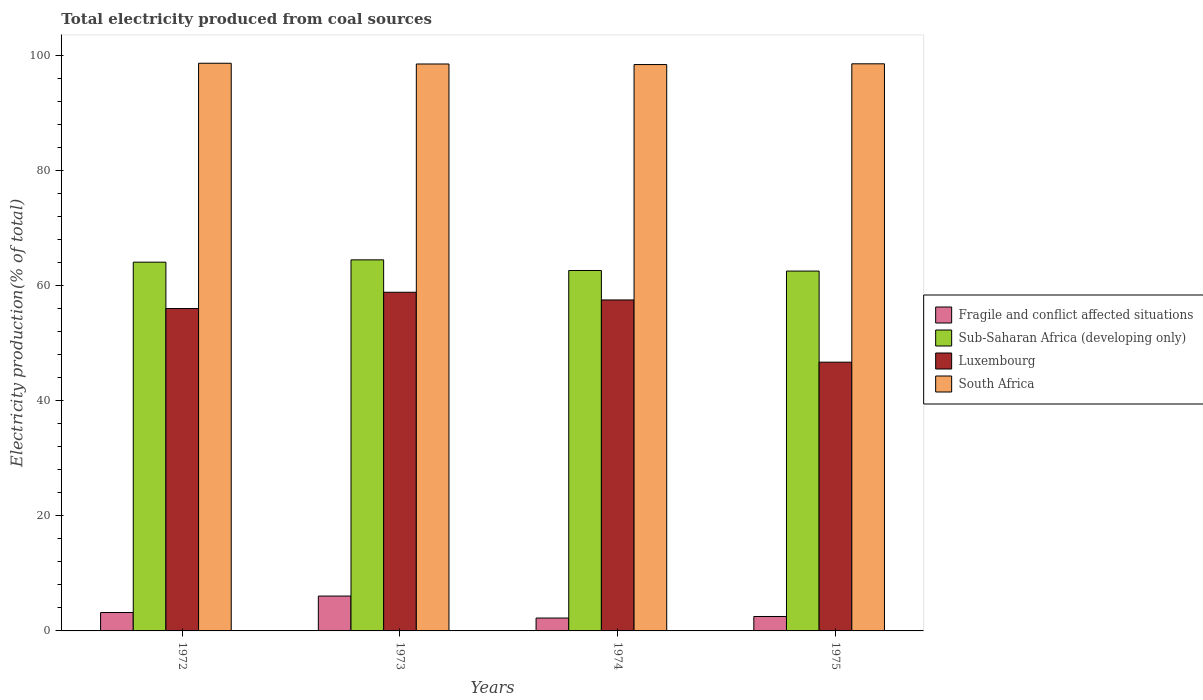Are the number of bars per tick equal to the number of legend labels?
Offer a terse response. Yes. What is the label of the 2nd group of bars from the left?
Ensure brevity in your answer.  1973. What is the total electricity produced in South Africa in 1972?
Your response must be concise. 98.6. Across all years, what is the maximum total electricity produced in Fragile and conflict affected situations?
Your response must be concise. 6.06. Across all years, what is the minimum total electricity produced in Sub-Saharan Africa (developing only)?
Your answer should be very brief. 62.5. In which year was the total electricity produced in South Africa maximum?
Give a very brief answer. 1972. In which year was the total electricity produced in Luxembourg minimum?
Make the answer very short. 1975. What is the total total electricity produced in Fragile and conflict affected situations in the graph?
Provide a succinct answer. 14. What is the difference between the total electricity produced in Fragile and conflict affected situations in 1973 and that in 1974?
Offer a very short reply. 3.82. What is the difference between the total electricity produced in Sub-Saharan Africa (developing only) in 1973 and the total electricity produced in Fragile and conflict affected situations in 1974?
Offer a terse response. 62.21. What is the average total electricity produced in Luxembourg per year?
Make the answer very short. 54.75. In the year 1975, what is the difference between the total electricity produced in Sub-Saharan Africa (developing only) and total electricity produced in Luxembourg?
Make the answer very short. 15.82. In how many years, is the total electricity produced in Sub-Saharan Africa (developing only) greater than 24 %?
Offer a very short reply. 4. What is the ratio of the total electricity produced in Fragile and conflict affected situations in 1972 to that in 1973?
Give a very brief answer. 0.53. Is the total electricity produced in Sub-Saharan Africa (developing only) in 1973 less than that in 1974?
Your answer should be compact. No. What is the difference between the highest and the second highest total electricity produced in Sub-Saharan Africa (developing only)?
Offer a terse response. 0.4. What is the difference between the highest and the lowest total electricity produced in Fragile and conflict affected situations?
Offer a very short reply. 3.82. Is the sum of the total electricity produced in Sub-Saharan Africa (developing only) in 1973 and 1975 greater than the maximum total electricity produced in Fragile and conflict affected situations across all years?
Ensure brevity in your answer.  Yes. Is it the case that in every year, the sum of the total electricity produced in South Africa and total electricity produced in Luxembourg is greater than the sum of total electricity produced in Sub-Saharan Africa (developing only) and total electricity produced in Fragile and conflict affected situations?
Your answer should be compact. Yes. What does the 3rd bar from the left in 1972 represents?
Your response must be concise. Luxembourg. What does the 2nd bar from the right in 1975 represents?
Ensure brevity in your answer.  Luxembourg. How many bars are there?
Offer a terse response. 16. Are all the bars in the graph horizontal?
Provide a succinct answer. No. How many years are there in the graph?
Ensure brevity in your answer.  4. Are the values on the major ticks of Y-axis written in scientific E-notation?
Offer a terse response. No. Does the graph contain grids?
Keep it short and to the point. No. Where does the legend appear in the graph?
Your answer should be compact. Center right. What is the title of the graph?
Provide a succinct answer. Total electricity produced from coal sources. Does "Antigua and Barbuda" appear as one of the legend labels in the graph?
Give a very brief answer. No. What is the label or title of the X-axis?
Ensure brevity in your answer.  Years. What is the Electricity production(% of total) of Fragile and conflict affected situations in 1972?
Make the answer very short. 3.2. What is the Electricity production(% of total) in Sub-Saharan Africa (developing only) in 1972?
Keep it short and to the point. 64.05. What is the Electricity production(% of total) in Luxembourg in 1972?
Ensure brevity in your answer.  55.99. What is the Electricity production(% of total) of South Africa in 1972?
Your answer should be compact. 98.6. What is the Electricity production(% of total) of Fragile and conflict affected situations in 1973?
Offer a terse response. 6.06. What is the Electricity production(% of total) of Sub-Saharan Africa (developing only) in 1973?
Provide a short and direct response. 64.45. What is the Electricity production(% of total) in Luxembourg in 1973?
Make the answer very short. 58.82. What is the Electricity production(% of total) in South Africa in 1973?
Offer a very short reply. 98.47. What is the Electricity production(% of total) of Fragile and conflict affected situations in 1974?
Your answer should be compact. 2.24. What is the Electricity production(% of total) in Sub-Saharan Africa (developing only) in 1974?
Offer a very short reply. 62.6. What is the Electricity production(% of total) of Luxembourg in 1974?
Offer a very short reply. 57.49. What is the Electricity production(% of total) of South Africa in 1974?
Ensure brevity in your answer.  98.37. What is the Electricity production(% of total) in Fragile and conflict affected situations in 1975?
Your answer should be very brief. 2.51. What is the Electricity production(% of total) of Sub-Saharan Africa (developing only) in 1975?
Ensure brevity in your answer.  62.5. What is the Electricity production(% of total) of Luxembourg in 1975?
Ensure brevity in your answer.  46.68. What is the Electricity production(% of total) in South Africa in 1975?
Make the answer very short. 98.5. Across all years, what is the maximum Electricity production(% of total) in Fragile and conflict affected situations?
Your answer should be very brief. 6.06. Across all years, what is the maximum Electricity production(% of total) in Sub-Saharan Africa (developing only)?
Make the answer very short. 64.45. Across all years, what is the maximum Electricity production(% of total) in Luxembourg?
Provide a short and direct response. 58.82. Across all years, what is the maximum Electricity production(% of total) in South Africa?
Keep it short and to the point. 98.6. Across all years, what is the minimum Electricity production(% of total) of Fragile and conflict affected situations?
Make the answer very short. 2.24. Across all years, what is the minimum Electricity production(% of total) of Sub-Saharan Africa (developing only)?
Make the answer very short. 62.5. Across all years, what is the minimum Electricity production(% of total) of Luxembourg?
Provide a succinct answer. 46.68. Across all years, what is the minimum Electricity production(% of total) of South Africa?
Your response must be concise. 98.37. What is the total Electricity production(% of total) of Fragile and conflict affected situations in the graph?
Your answer should be compact. 14. What is the total Electricity production(% of total) in Sub-Saharan Africa (developing only) in the graph?
Ensure brevity in your answer.  253.61. What is the total Electricity production(% of total) of Luxembourg in the graph?
Your answer should be very brief. 218.98. What is the total Electricity production(% of total) in South Africa in the graph?
Make the answer very short. 393.95. What is the difference between the Electricity production(% of total) of Fragile and conflict affected situations in 1972 and that in 1973?
Provide a succinct answer. -2.86. What is the difference between the Electricity production(% of total) in Sub-Saharan Africa (developing only) in 1972 and that in 1973?
Offer a terse response. -0.4. What is the difference between the Electricity production(% of total) of Luxembourg in 1972 and that in 1973?
Make the answer very short. -2.83. What is the difference between the Electricity production(% of total) in South Africa in 1972 and that in 1973?
Keep it short and to the point. 0.13. What is the difference between the Electricity production(% of total) of Fragile and conflict affected situations in 1972 and that in 1974?
Keep it short and to the point. 0.96. What is the difference between the Electricity production(% of total) of Sub-Saharan Africa (developing only) in 1972 and that in 1974?
Ensure brevity in your answer.  1.45. What is the difference between the Electricity production(% of total) of Luxembourg in 1972 and that in 1974?
Offer a terse response. -1.49. What is the difference between the Electricity production(% of total) of South Africa in 1972 and that in 1974?
Give a very brief answer. 0.22. What is the difference between the Electricity production(% of total) in Fragile and conflict affected situations in 1972 and that in 1975?
Your answer should be compact. 0.69. What is the difference between the Electricity production(% of total) in Sub-Saharan Africa (developing only) in 1972 and that in 1975?
Offer a terse response. 1.55. What is the difference between the Electricity production(% of total) in Luxembourg in 1972 and that in 1975?
Your answer should be very brief. 9.31. What is the difference between the Electricity production(% of total) in South Africa in 1972 and that in 1975?
Ensure brevity in your answer.  0.09. What is the difference between the Electricity production(% of total) in Fragile and conflict affected situations in 1973 and that in 1974?
Keep it short and to the point. 3.82. What is the difference between the Electricity production(% of total) of Sub-Saharan Africa (developing only) in 1973 and that in 1974?
Ensure brevity in your answer.  1.85. What is the difference between the Electricity production(% of total) in Luxembourg in 1973 and that in 1974?
Keep it short and to the point. 1.34. What is the difference between the Electricity production(% of total) of South Africa in 1973 and that in 1974?
Keep it short and to the point. 0.1. What is the difference between the Electricity production(% of total) of Fragile and conflict affected situations in 1973 and that in 1975?
Offer a terse response. 3.55. What is the difference between the Electricity production(% of total) of Sub-Saharan Africa (developing only) in 1973 and that in 1975?
Your answer should be compact. 1.95. What is the difference between the Electricity production(% of total) in Luxembourg in 1973 and that in 1975?
Your answer should be compact. 12.14. What is the difference between the Electricity production(% of total) in South Africa in 1973 and that in 1975?
Offer a terse response. -0.03. What is the difference between the Electricity production(% of total) of Fragile and conflict affected situations in 1974 and that in 1975?
Your answer should be very brief. -0.27. What is the difference between the Electricity production(% of total) in Sub-Saharan Africa (developing only) in 1974 and that in 1975?
Provide a short and direct response. 0.1. What is the difference between the Electricity production(% of total) of Luxembourg in 1974 and that in 1975?
Offer a very short reply. 10.81. What is the difference between the Electricity production(% of total) of South Africa in 1974 and that in 1975?
Provide a succinct answer. -0.13. What is the difference between the Electricity production(% of total) in Fragile and conflict affected situations in 1972 and the Electricity production(% of total) in Sub-Saharan Africa (developing only) in 1973?
Give a very brief answer. -61.26. What is the difference between the Electricity production(% of total) in Fragile and conflict affected situations in 1972 and the Electricity production(% of total) in Luxembourg in 1973?
Ensure brevity in your answer.  -55.63. What is the difference between the Electricity production(% of total) of Fragile and conflict affected situations in 1972 and the Electricity production(% of total) of South Africa in 1973?
Offer a terse response. -95.27. What is the difference between the Electricity production(% of total) in Sub-Saharan Africa (developing only) in 1972 and the Electricity production(% of total) in Luxembourg in 1973?
Your answer should be compact. 5.23. What is the difference between the Electricity production(% of total) of Sub-Saharan Africa (developing only) in 1972 and the Electricity production(% of total) of South Africa in 1973?
Provide a succinct answer. -34.42. What is the difference between the Electricity production(% of total) of Luxembourg in 1972 and the Electricity production(% of total) of South Africa in 1973?
Offer a very short reply. -42.48. What is the difference between the Electricity production(% of total) of Fragile and conflict affected situations in 1972 and the Electricity production(% of total) of Sub-Saharan Africa (developing only) in 1974?
Your response must be concise. -59.41. What is the difference between the Electricity production(% of total) of Fragile and conflict affected situations in 1972 and the Electricity production(% of total) of Luxembourg in 1974?
Offer a very short reply. -54.29. What is the difference between the Electricity production(% of total) in Fragile and conflict affected situations in 1972 and the Electricity production(% of total) in South Africa in 1974?
Provide a succinct answer. -95.18. What is the difference between the Electricity production(% of total) in Sub-Saharan Africa (developing only) in 1972 and the Electricity production(% of total) in Luxembourg in 1974?
Your response must be concise. 6.56. What is the difference between the Electricity production(% of total) in Sub-Saharan Africa (developing only) in 1972 and the Electricity production(% of total) in South Africa in 1974?
Your answer should be very brief. -34.32. What is the difference between the Electricity production(% of total) of Luxembourg in 1972 and the Electricity production(% of total) of South Africa in 1974?
Offer a very short reply. -42.38. What is the difference between the Electricity production(% of total) in Fragile and conflict affected situations in 1972 and the Electricity production(% of total) in Sub-Saharan Africa (developing only) in 1975?
Make the answer very short. -59.31. What is the difference between the Electricity production(% of total) in Fragile and conflict affected situations in 1972 and the Electricity production(% of total) in Luxembourg in 1975?
Make the answer very short. -43.48. What is the difference between the Electricity production(% of total) of Fragile and conflict affected situations in 1972 and the Electricity production(% of total) of South Africa in 1975?
Offer a very short reply. -95.31. What is the difference between the Electricity production(% of total) of Sub-Saharan Africa (developing only) in 1972 and the Electricity production(% of total) of Luxembourg in 1975?
Ensure brevity in your answer.  17.37. What is the difference between the Electricity production(% of total) of Sub-Saharan Africa (developing only) in 1972 and the Electricity production(% of total) of South Africa in 1975?
Give a very brief answer. -34.45. What is the difference between the Electricity production(% of total) in Luxembourg in 1972 and the Electricity production(% of total) in South Africa in 1975?
Make the answer very short. -42.51. What is the difference between the Electricity production(% of total) in Fragile and conflict affected situations in 1973 and the Electricity production(% of total) in Sub-Saharan Africa (developing only) in 1974?
Your response must be concise. -56.55. What is the difference between the Electricity production(% of total) in Fragile and conflict affected situations in 1973 and the Electricity production(% of total) in Luxembourg in 1974?
Make the answer very short. -51.43. What is the difference between the Electricity production(% of total) in Fragile and conflict affected situations in 1973 and the Electricity production(% of total) in South Africa in 1974?
Provide a succinct answer. -92.32. What is the difference between the Electricity production(% of total) of Sub-Saharan Africa (developing only) in 1973 and the Electricity production(% of total) of Luxembourg in 1974?
Give a very brief answer. 6.97. What is the difference between the Electricity production(% of total) in Sub-Saharan Africa (developing only) in 1973 and the Electricity production(% of total) in South Africa in 1974?
Provide a succinct answer. -33.92. What is the difference between the Electricity production(% of total) of Luxembourg in 1973 and the Electricity production(% of total) of South Africa in 1974?
Ensure brevity in your answer.  -39.55. What is the difference between the Electricity production(% of total) in Fragile and conflict affected situations in 1973 and the Electricity production(% of total) in Sub-Saharan Africa (developing only) in 1975?
Provide a short and direct response. -56.45. What is the difference between the Electricity production(% of total) in Fragile and conflict affected situations in 1973 and the Electricity production(% of total) in Luxembourg in 1975?
Your response must be concise. -40.62. What is the difference between the Electricity production(% of total) in Fragile and conflict affected situations in 1973 and the Electricity production(% of total) in South Africa in 1975?
Ensure brevity in your answer.  -92.45. What is the difference between the Electricity production(% of total) of Sub-Saharan Africa (developing only) in 1973 and the Electricity production(% of total) of Luxembourg in 1975?
Ensure brevity in your answer.  17.77. What is the difference between the Electricity production(% of total) of Sub-Saharan Africa (developing only) in 1973 and the Electricity production(% of total) of South Africa in 1975?
Make the answer very short. -34.05. What is the difference between the Electricity production(% of total) in Luxembourg in 1973 and the Electricity production(% of total) in South Africa in 1975?
Keep it short and to the point. -39.68. What is the difference between the Electricity production(% of total) of Fragile and conflict affected situations in 1974 and the Electricity production(% of total) of Sub-Saharan Africa (developing only) in 1975?
Make the answer very short. -60.26. What is the difference between the Electricity production(% of total) in Fragile and conflict affected situations in 1974 and the Electricity production(% of total) in Luxembourg in 1975?
Give a very brief answer. -44.44. What is the difference between the Electricity production(% of total) in Fragile and conflict affected situations in 1974 and the Electricity production(% of total) in South Africa in 1975?
Provide a succinct answer. -96.27. What is the difference between the Electricity production(% of total) of Sub-Saharan Africa (developing only) in 1974 and the Electricity production(% of total) of Luxembourg in 1975?
Make the answer very short. 15.92. What is the difference between the Electricity production(% of total) in Sub-Saharan Africa (developing only) in 1974 and the Electricity production(% of total) in South Africa in 1975?
Ensure brevity in your answer.  -35.9. What is the difference between the Electricity production(% of total) in Luxembourg in 1974 and the Electricity production(% of total) in South Africa in 1975?
Your answer should be very brief. -41.02. What is the average Electricity production(% of total) in Fragile and conflict affected situations per year?
Your response must be concise. 3.5. What is the average Electricity production(% of total) in Sub-Saharan Africa (developing only) per year?
Make the answer very short. 63.4. What is the average Electricity production(% of total) in Luxembourg per year?
Keep it short and to the point. 54.75. What is the average Electricity production(% of total) of South Africa per year?
Your answer should be very brief. 98.49. In the year 1972, what is the difference between the Electricity production(% of total) in Fragile and conflict affected situations and Electricity production(% of total) in Sub-Saharan Africa (developing only)?
Your answer should be very brief. -60.86. In the year 1972, what is the difference between the Electricity production(% of total) of Fragile and conflict affected situations and Electricity production(% of total) of Luxembourg?
Your answer should be very brief. -52.8. In the year 1972, what is the difference between the Electricity production(% of total) of Fragile and conflict affected situations and Electricity production(% of total) of South Africa?
Your response must be concise. -95.4. In the year 1972, what is the difference between the Electricity production(% of total) in Sub-Saharan Africa (developing only) and Electricity production(% of total) in Luxembourg?
Make the answer very short. 8.06. In the year 1972, what is the difference between the Electricity production(% of total) of Sub-Saharan Africa (developing only) and Electricity production(% of total) of South Africa?
Provide a short and direct response. -34.55. In the year 1972, what is the difference between the Electricity production(% of total) of Luxembourg and Electricity production(% of total) of South Africa?
Your response must be concise. -42.6. In the year 1973, what is the difference between the Electricity production(% of total) in Fragile and conflict affected situations and Electricity production(% of total) in Sub-Saharan Africa (developing only)?
Provide a short and direct response. -58.4. In the year 1973, what is the difference between the Electricity production(% of total) in Fragile and conflict affected situations and Electricity production(% of total) in Luxembourg?
Provide a succinct answer. -52.77. In the year 1973, what is the difference between the Electricity production(% of total) of Fragile and conflict affected situations and Electricity production(% of total) of South Africa?
Keep it short and to the point. -92.41. In the year 1973, what is the difference between the Electricity production(% of total) of Sub-Saharan Africa (developing only) and Electricity production(% of total) of Luxembourg?
Make the answer very short. 5.63. In the year 1973, what is the difference between the Electricity production(% of total) in Sub-Saharan Africa (developing only) and Electricity production(% of total) in South Africa?
Provide a succinct answer. -34.02. In the year 1973, what is the difference between the Electricity production(% of total) in Luxembourg and Electricity production(% of total) in South Africa?
Offer a very short reply. -39.65. In the year 1974, what is the difference between the Electricity production(% of total) of Fragile and conflict affected situations and Electricity production(% of total) of Sub-Saharan Africa (developing only)?
Your response must be concise. -60.36. In the year 1974, what is the difference between the Electricity production(% of total) of Fragile and conflict affected situations and Electricity production(% of total) of Luxembourg?
Give a very brief answer. -55.25. In the year 1974, what is the difference between the Electricity production(% of total) of Fragile and conflict affected situations and Electricity production(% of total) of South Africa?
Make the answer very short. -96.14. In the year 1974, what is the difference between the Electricity production(% of total) in Sub-Saharan Africa (developing only) and Electricity production(% of total) in Luxembourg?
Make the answer very short. 5.12. In the year 1974, what is the difference between the Electricity production(% of total) in Sub-Saharan Africa (developing only) and Electricity production(% of total) in South Africa?
Your response must be concise. -35.77. In the year 1974, what is the difference between the Electricity production(% of total) of Luxembourg and Electricity production(% of total) of South Africa?
Offer a very short reply. -40.89. In the year 1975, what is the difference between the Electricity production(% of total) in Fragile and conflict affected situations and Electricity production(% of total) in Sub-Saharan Africa (developing only)?
Make the answer very short. -60. In the year 1975, what is the difference between the Electricity production(% of total) in Fragile and conflict affected situations and Electricity production(% of total) in Luxembourg?
Your answer should be compact. -44.17. In the year 1975, what is the difference between the Electricity production(% of total) in Fragile and conflict affected situations and Electricity production(% of total) in South Africa?
Your answer should be compact. -96. In the year 1975, what is the difference between the Electricity production(% of total) in Sub-Saharan Africa (developing only) and Electricity production(% of total) in Luxembourg?
Keep it short and to the point. 15.82. In the year 1975, what is the difference between the Electricity production(% of total) of Sub-Saharan Africa (developing only) and Electricity production(% of total) of South Africa?
Offer a terse response. -36. In the year 1975, what is the difference between the Electricity production(% of total) of Luxembourg and Electricity production(% of total) of South Africa?
Offer a very short reply. -51.83. What is the ratio of the Electricity production(% of total) in Fragile and conflict affected situations in 1972 to that in 1973?
Your answer should be very brief. 0.53. What is the ratio of the Electricity production(% of total) of Luxembourg in 1972 to that in 1973?
Give a very brief answer. 0.95. What is the ratio of the Electricity production(% of total) in Fragile and conflict affected situations in 1972 to that in 1974?
Your response must be concise. 1.43. What is the ratio of the Electricity production(% of total) in Sub-Saharan Africa (developing only) in 1972 to that in 1974?
Offer a very short reply. 1.02. What is the ratio of the Electricity production(% of total) of South Africa in 1972 to that in 1974?
Your answer should be compact. 1. What is the ratio of the Electricity production(% of total) of Fragile and conflict affected situations in 1972 to that in 1975?
Keep it short and to the point. 1.27. What is the ratio of the Electricity production(% of total) in Sub-Saharan Africa (developing only) in 1972 to that in 1975?
Make the answer very short. 1.02. What is the ratio of the Electricity production(% of total) of Luxembourg in 1972 to that in 1975?
Your answer should be very brief. 1.2. What is the ratio of the Electricity production(% of total) in South Africa in 1972 to that in 1975?
Keep it short and to the point. 1. What is the ratio of the Electricity production(% of total) in Fragile and conflict affected situations in 1973 to that in 1974?
Offer a terse response. 2.71. What is the ratio of the Electricity production(% of total) of Sub-Saharan Africa (developing only) in 1973 to that in 1974?
Offer a very short reply. 1.03. What is the ratio of the Electricity production(% of total) in Luxembourg in 1973 to that in 1974?
Your answer should be compact. 1.02. What is the ratio of the Electricity production(% of total) in South Africa in 1973 to that in 1974?
Provide a short and direct response. 1. What is the ratio of the Electricity production(% of total) in Fragile and conflict affected situations in 1973 to that in 1975?
Keep it short and to the point. 2.42. What is the ratio of the Electricity production(% of total) in Sub-Saharan Africa (developing only) in 1973 to that in 1975?
Make the answer very short. 1.03. What is the ratio of the Electricity production(% of total) in Luxembourg in 1973 to that in 1975?
Offer a very short reply. 1.26. What is the ratio of the Electricity production(% of total) in South Africa in 1973 to that in 1975?
Provide a succinct answer. 1. What is the ratio of the Electricity production(% of total) in Fragile and conflict affected situations in 1974 to that in 1975?
Ensure brevity in your answer.  0.89. What is the ratio of the Electricity production(% of total) of Luxembourg in 1974 to that in 1975?
Provide a short and direct response. 1.23. What is the difference between the highest and the second highest Electricity production(% of total) in Fragile and conflict affected situations?
Provide a succinct answer. 2.86. What is the difference between the highest and the second highest Electricity production(% of total) in Sub-Saharan Africa (developing only)?
Provide a short and direct response. 0.4. What is the difference between the highest and the second highest Electricity production(% of total) of Luxembourg?
Make the answer very short. 1.34. What is the difference between the highest and the second highest Electricity production(% of total) in South Africa?
Offer a terse response. 0.09. What is the difference between the highest and the lowest Electricity production(% of total) in Fragile and conflict affected situations?
Make the answer very short. 3.82. What is the difference between the highest and the lowest Electricity production(% of total) of Sub-Saharan Africa (developing only)?
Your answer should be compact. 1.95. What is the difference between the highest and the lowest Electricity production(% of total) of Luxembourg?
Keep it short and to the point. 12.14. What is the difference between the highest and the lowest Electricity production(% of total) of South Africa?
Provide a succinct answer. 0.22. 